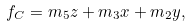Convert formula to latex. <formula><loc_0><loc_0><loc_500><loc_500>f _ { C } = m _ { 5 } z + m _ { 3 } x + m _ { 2 } y ,</formula> 